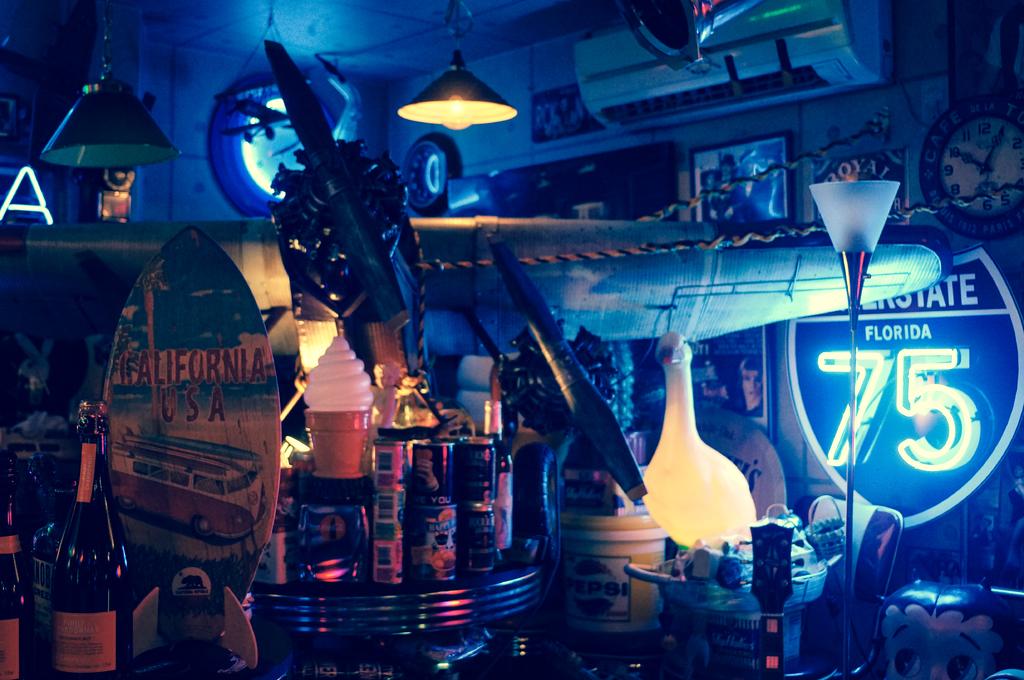What's the number on the right?
Keep it short and to the point. 75. What state is on the interstate sign?
Provide a succinct answer. Florida. 